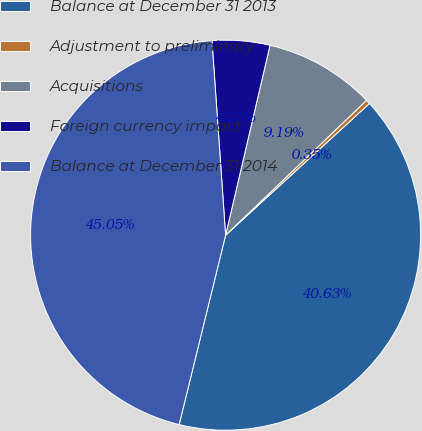<chart> <loc_0><loc_0><loc_500><loc_500><pie_chart><fcel>Balance at December 31 2013<fcel>Adjustment to preliminary<fcel>Acquisitions<fcel>Foreign currency impact<fcel>Balance at December 31 2014<nl><fcel>40.63%<fcel>0.35%<fcel>9.19%<fcel>4.77%<fcel>45.05%<nl></chart> 